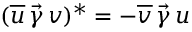Convert formula to latex. <formula><loc_0><loc_0><loc_500><loc_500>( \overline { u } \, \vec { \gamma } \, v ) ^ { * } = - \overline { v } \, \vec { \gamma } \, u</formula> 